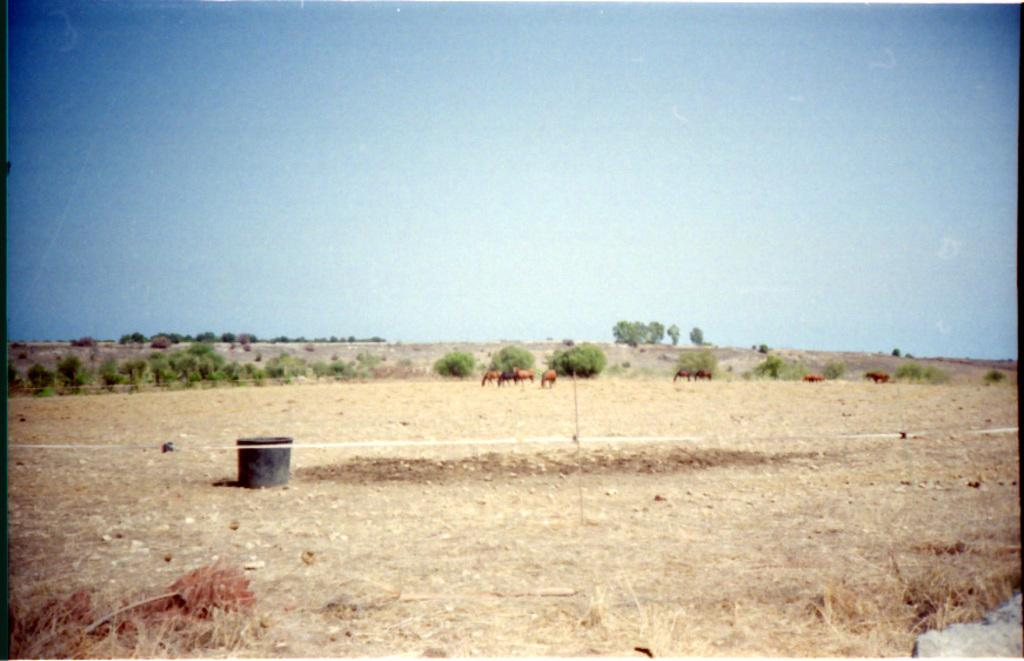What is the general appearance of the landscape in the image? The image depicts a barren land. What object can be seen on the ground in the center of the image? There is a box on the ground in the center of the image. What type of animals can be seen in the background of the image? There are a few animals visible in the background. What type of vegetation is present in the background of the image? Trees are present in the background. What is visible at the top of the image? The sky is visible at the top of the image. What type of church can be seen in the background of the image? There is no church present in the image; it depicts a barren land with a box on the ground and a few animals and trees in the background. How many snakes are visible in the image? There are no snakes visible in the image; it features a barren land with a box, animals, trees, and a sky. 